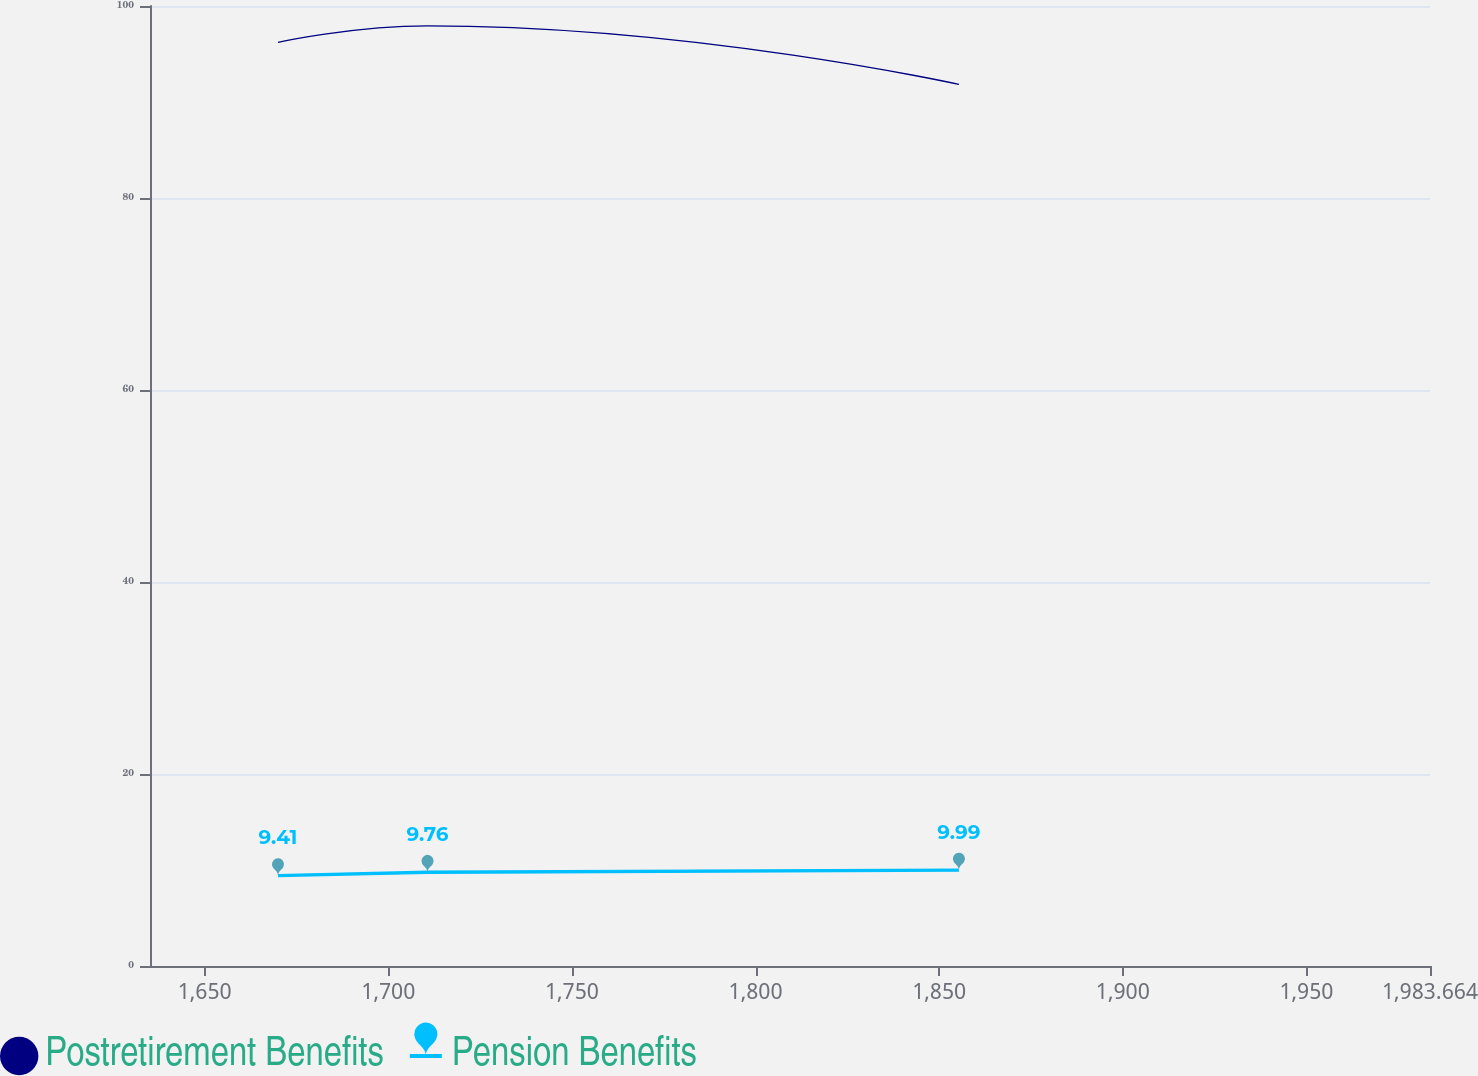<chart> <loc_0><loc_0><loc_500><loc_500><line_chart><ecel><fcel>Postretirement Benefits<fcel>Pension Benefits<nl><fcel>1669.96<fcel>96.21<fcel>9.41<nl><fcel>1710.68<fcel>97.93<fcel>9.76<nl><fcel>1855.38<fcel>91.83<fcel>9.99<nl><fcel>1986.41<fcel>90.11<fcel>8.95<nl><fcel>2018.52<fcel>107.28<fcel>11.01<nl></chart> 